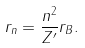Convert formula to latex. <formula><loc_0><loc_0><loc_500><loc_500>r _ { n } = \frac { n ^ { 2 } } { Z ^ { \prime } } r _ { B } .</formula> 